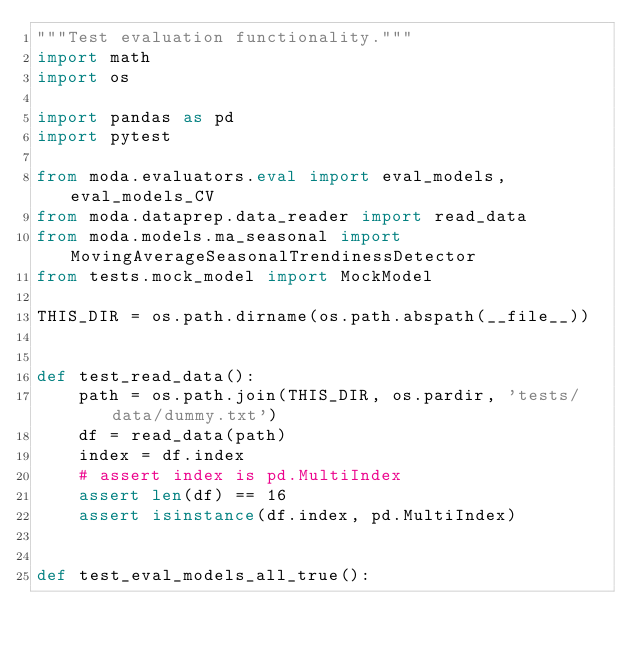Convert code to text. <code><loc_0><loc_0><loc_500><loc_500><_Python_>"""Test evaluation functionality."""
import math
import os

import pandas as pd
import pytest

from moda.evaluators.eval import eval_models, eval_models_CV
from moda.dataprep.data_reader import read_data
from moda.models.ma_seasonal import MovingAverageSeasonalTrendinessDetector
from tests.mock_model import MockModel

THIS_DIR = os.path.dirname(os.path.abspath(__file__))


def test_read_data():
    path = os.path.join(THIS_DIR, os.pardir, 'tests/data/dummy.txt')
    df = read_data(path)
    index = df.index
    # assert index is pd.MultiIndex
    assert len(df) == 16
    assert isinstance(df.index, pd.MultiIndex)


def test_eval_models_all_true():</code> 